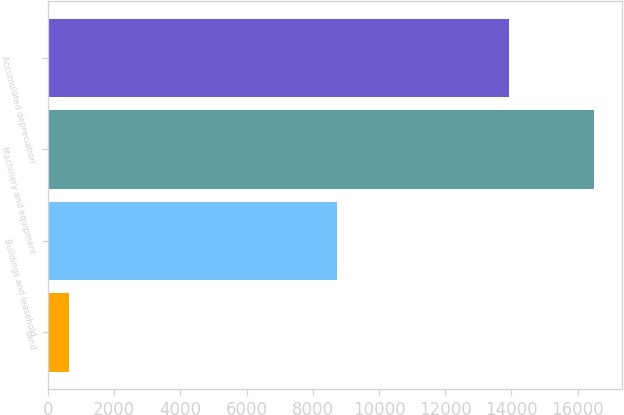Convert chart to OTSL. <chart><loc_0><loc_0><loc_500><loc_500><bar_chart><fcel>Land<fcel>Buildings and leasehold<fcel>Machinery and equipment<fcel>Accumulated depreciation<nl><fcel>636<fcel>8744<fcel>16503<fcel>13929<nl></chart> 